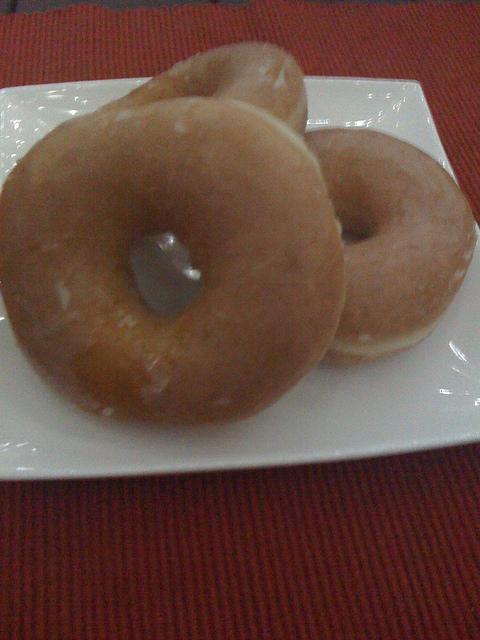How many donuts are on the plate?
Give a very brief answer. 3. How many donuts can be seen?
Give a very brief answer. 3. 